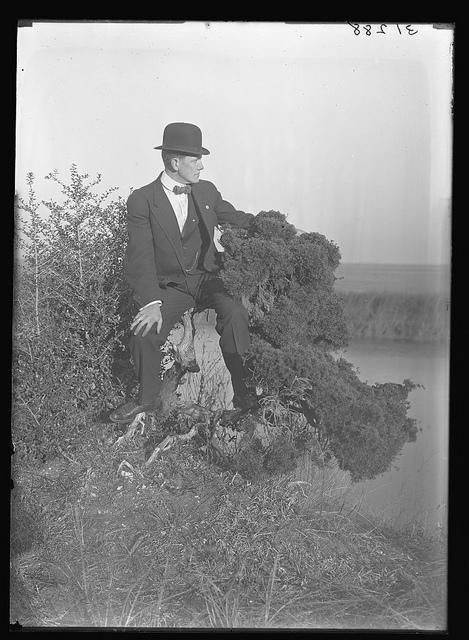How many people are wearing hats?
Give a very brief answer. 1. How many people are wearing hats in this photo?
Give a very brief answer. 1. 